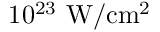Convert formula to latex. <formula><loc_0><loc_0><loc_500><loc_500>1 0 ^ { 2 3 } \ W / c m ^ { 2 }</formula> 